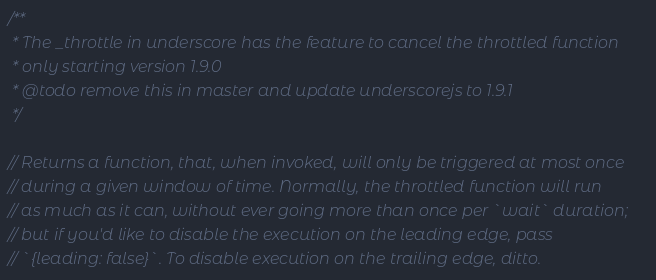<code> <loc_0><loc_0><loc_500><loc_500><_JavaScript_>/**
 * The _throttle in underscore has the feature to cancel the throttled function
 * only starting version 1.9.0
 * @todo remove this in master and update underscorejs to 1.9.1
 */

// Returns a function, that, when invoked, will only be triggered at most once
// during a given window of time. Normally, the throttled function will run
// as much as it can, without ever going more than once per `wait` duration;
// but if you'd like to disable the execution on the leading edge, pass
// `{leading: false}`. To disable execution on the trailing edge, ditto.
</code> 